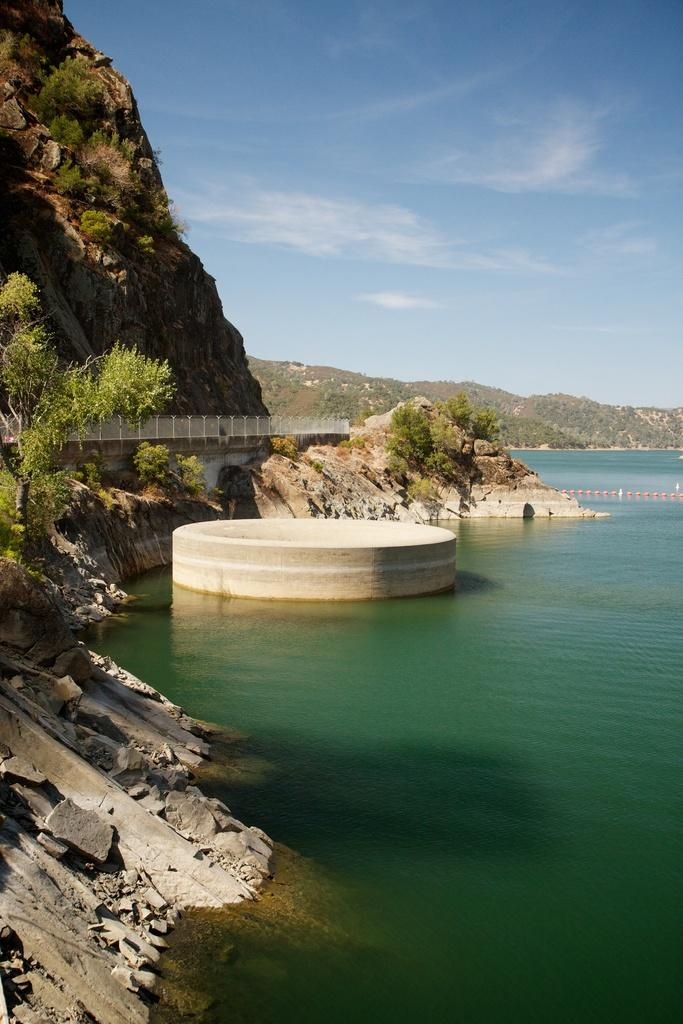What is the primary feature of the landscape in the image? There is a water surface in the image. What type of geographical feature can be seen in the background? There are mountains visible in the image. What type of vegetation is present in the image? There are trees in the image. What is visible in the sky at the top of the image? Clouds are present in the sky at the top of the image. Can you see the ear of the person who took the photo in the image? There is no person or ear visible in the image; it features a landscape with a water surface, mountains, trees, and clouds. 